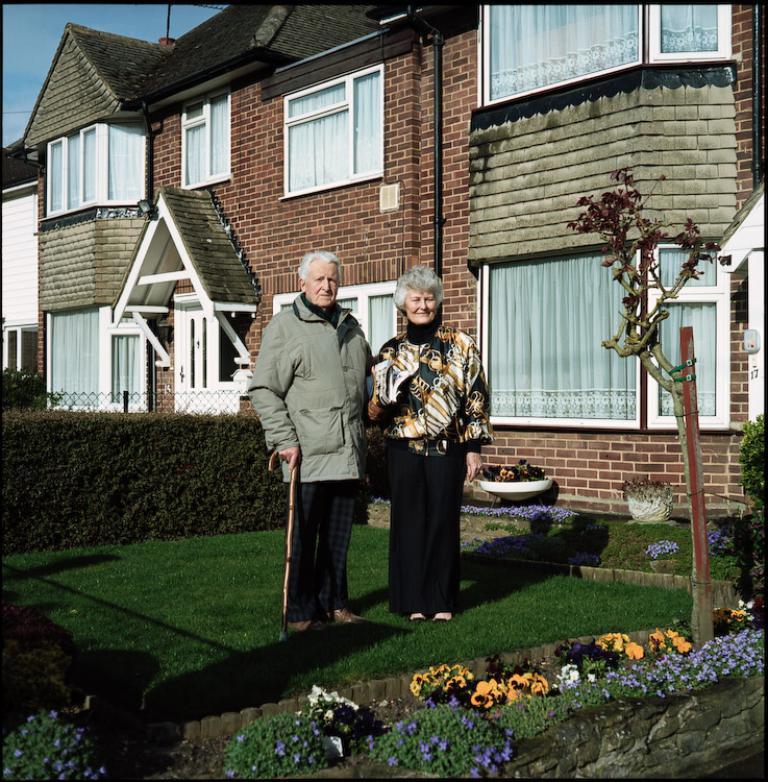Please provide a concise description of this image. In this image in the center there is one man and one woman who are standing, at the bottom there is some grass and some plants and flowers. In the background there is a house and one pole, and on the right side there is one plant and iron rod. 